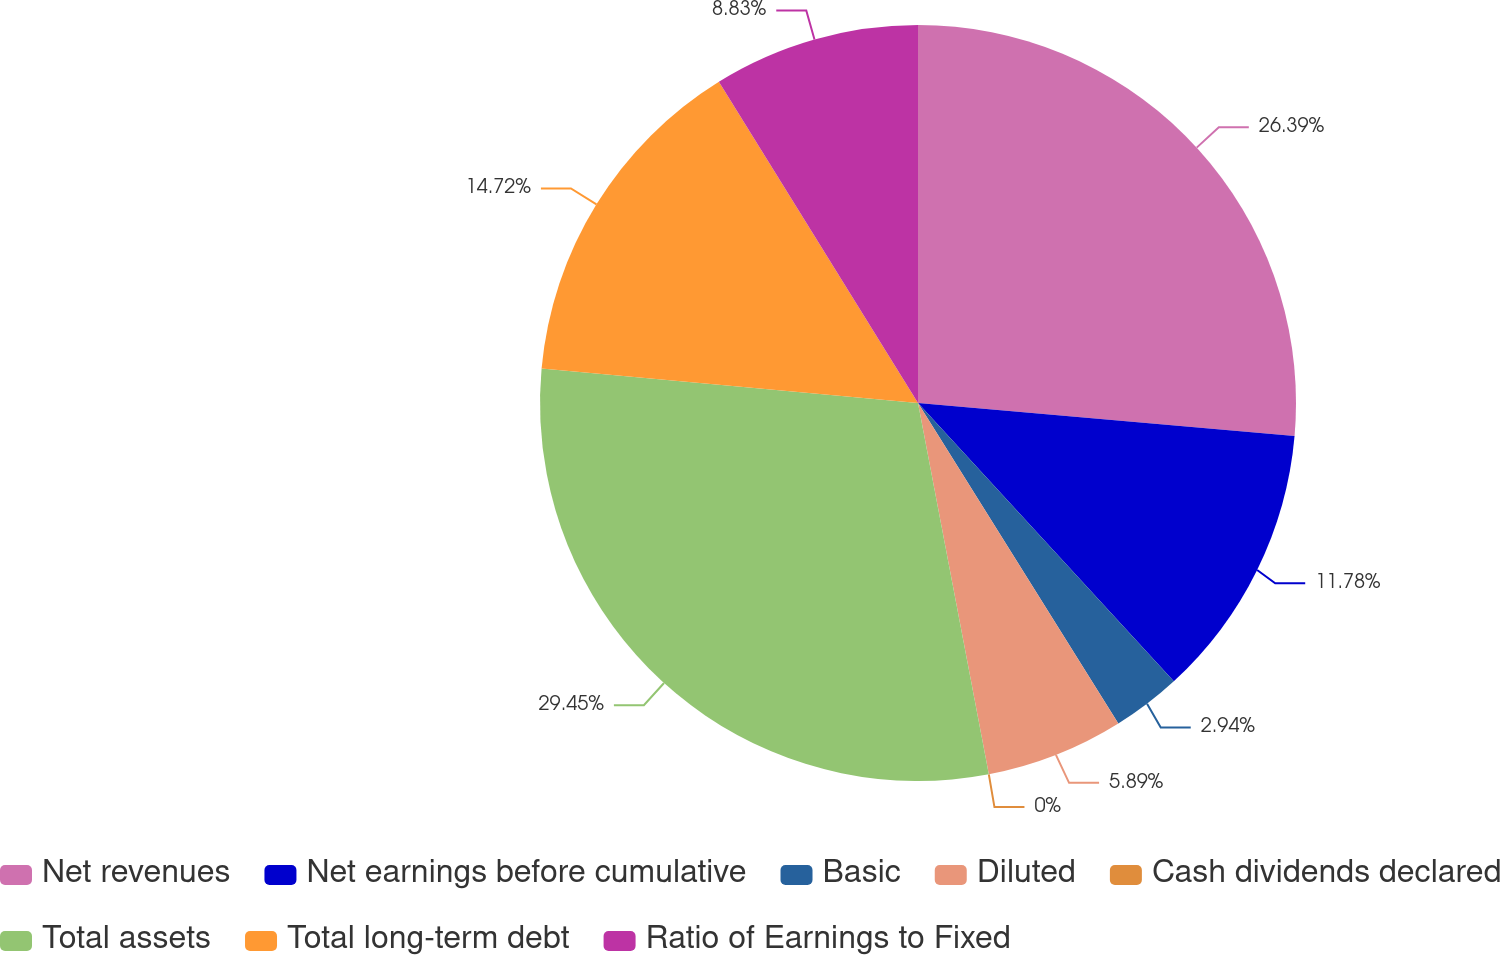Convert chart to OTSL. <chart><loc_0><loc_0><loc_500><loc_500><pie_chart><fcel>Net revenues<fcel>Net earnings before cumulative<fcel>Basic<fcel>Diluted<fcel>Cash dividends declared<fcel>Total assets<fcel>Total long-term debt<fcel>Ratio of Earnings to Fixed<nl><fcel>26.39%<fcel>11.78%<fcel>2.94%<fcel>5.89%<fcel>0.0%<fcel>29.45%<fcel>14.72%<fcel>8.83%<nl></chart> 